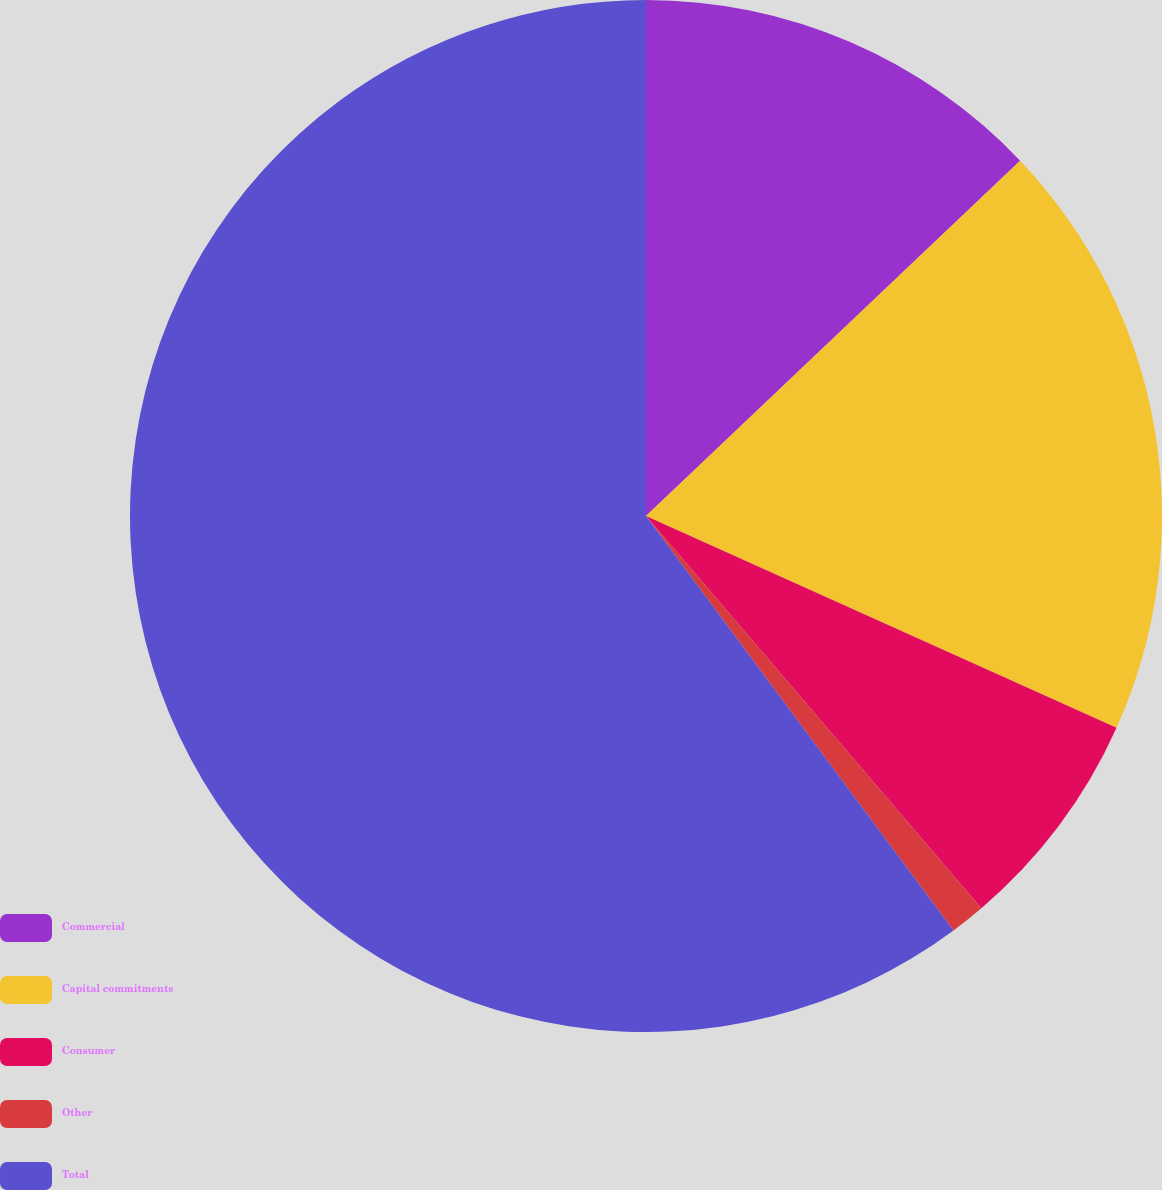Convert chart to OTSL. <chart><loc_0><loc_0><loc_500><loc_500><pie_chart><fcel>Commercial<fcel>Capital commitments<fcel>Consumer<fcel>Other<fcel>Total<nl><fcel>12.91%<fcel>18.82%<fcel>7.01%<fcel>1.1%<fcel>60.16%<nl></chart> 